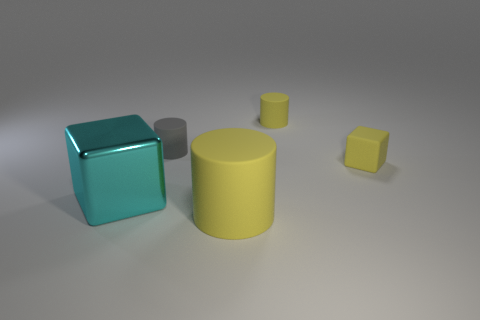Add 1 yellow matte balls. How many objects exist? 6 Subtract all cylinders. How many objects are left? 2 Add 5 large blocks. How many large blocks exist? 6 Subtract 0 blue cylinders. How many objects are left? 5 Subtract all small yellow rubber objects. Subtract all gray matte objects. How many objects are left? 2 Add 3 small cylinders. How many small cylinders are left? 5 